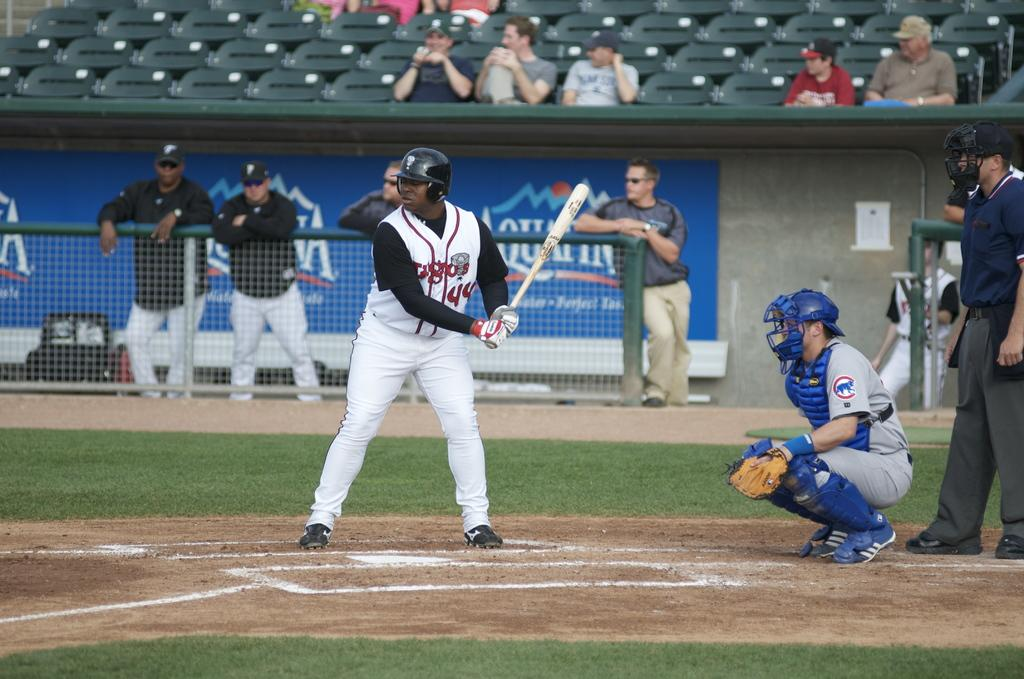Provide a one-sentence caption for the provided image. A batter is in position in front of a banner for Aquafina water. 